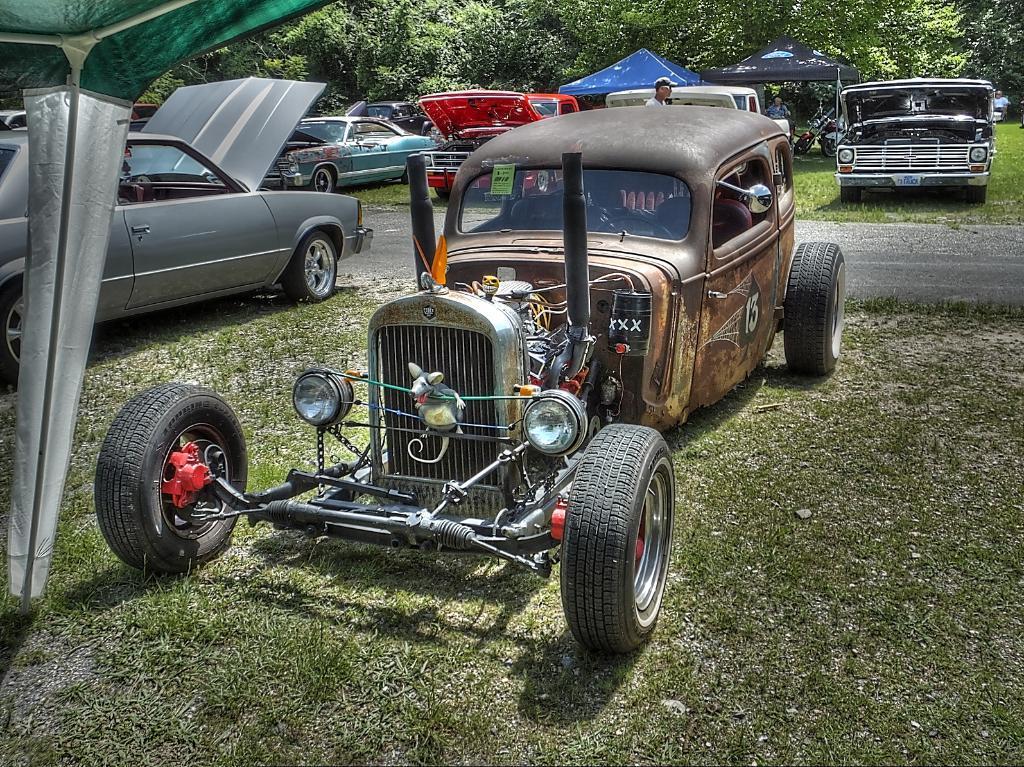In one or two sentences, can you explain what this image depicts? In this picture there are vehicles. At the back there is a person standing under the tent and there is a person walking on the road and there are trees. At the bottom there is a road and there is grass. 